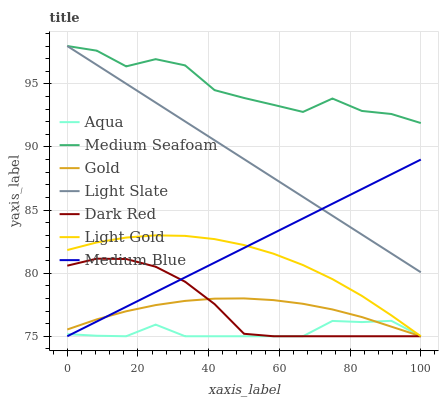Does Aqua have the minimum area under the curve?
Answer yes or no. Yes. Does Medium Seafoam have the maximum area under the curve?
Answer yes or no. Yes. Does Light Slate have the minimum area under the curve?
Answer yes or no. No. Does Light Slate have the maximum area under the curve?
Answer yes or no. No. Is Medium Blue the smoothest?
Answer yes or no. Yes. Is Medium Seafoam the roughest?
Answer yes or no. Yes. Is Light Slate the smoothest?
Answer yes or no. No. Is Light Slate the roughest?
Answer yes or no. No. Does Gold have the lowest value?
Answer yes or no. Yes. Does Light Slate have the lowest value?
Answer yes or no. No. Does Medium Seafoam have the highest value?
Answer yes or no. Yes. Does Dark Red have the highest value?
Answer yes or no. No. Is Light Gold less than Light Slate?
Answer yes or no. Yes. Is Light Slate greater than Gold?
Answer yes or no. Yes. Does Light Gold intersect Gold?
Answer yes or no. Yes. Is Light Gold less than Gold?
Answer yes or no. No. Is Light Gold greater than Gold?
Answer yes or no. No. Does Light Gold intersect Light Slate?
Answer yes or no. No. 